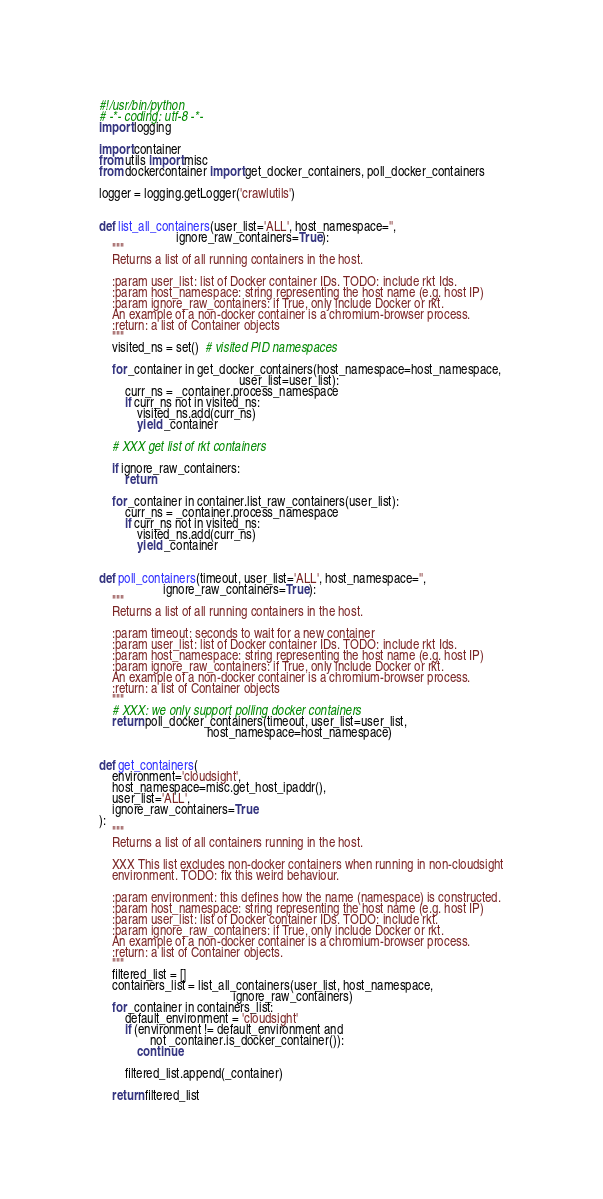<code> <loc_0><loc_0><loc_500><loc_500><_Python_>#!/usr/bin/python
# -*- coding: utf-8 -*-
import logging

import container
from utils import misc
from dockercontainer import get_docker_containers, poll_docker_containers

logger = logging.getLogger('crawlutils')


def list_all_containers(user_list='ALL', host_namespace='',
                        ignore_raw_containers=True):
    """
    Returns a list of all running containers in the host.

    :param user_list: list of Docker container IDs. TODO: include rkt Ids.
    :param host_namespace: string representing the host name (e.g. host IP)
    :param ignore_raw_containers: if True, only include Docker or rkt.
    An example of a non-docker container is a chromium-browser process.
    :return: a list of Container objects
    """
    visited_ns = set()  # visited PID namespaces

    for _container in get_docker_containers(host_namespace=host_namespace,
                                            user_list=user_list):
        curr_ns = _container.process_namespace
        if curr_ns not in visited_ns:
            visited_ns.add(curr_ns)
            yield _container

    # XXX get list of rkt containers

    if ignore_raw_containers:
        return

    for _container in container.list_raw_containers(user_list):
        curr_ns = _container.process_namespace
        if curr_ns not in visited_ns:
            visited_ns.add(curr_ns)
            yield _container


def poll_containers(timeout, user_list='ALL', host_namespace='',
                    ignore_raw_containers=True):
    """
    Returns a list of all running containers in the host.

    :param timeout: seconds to wait for a new container
    :param user_list: list of Docker container IDs. TODO: include rkt Ids.
    :param host_namespace: string representing the host name (e.g. host IP)
    :param ignore_raw_containers: if True, only include Docker or rkt.
    An example of a non-docker container is a chromium-browser process.
    :return: a list of Container objects
    """
    # XXX: we only support polling docker containers
    return poll_docker_containers(timeout, user_list=user_list,
                                  host_namespace=host_namespace)


def get_containers(
    environment='cloudsight',
    host_namespace=misc.get_host_ipaddr(),
    user_list='ALL',
    ignore_raw_containers=True
):
    """
    Returns a list of all containers running in the host.

    XXX This list excludes non-docker containers when running in non-cloudsight
    environment. TODO: fix this weird behaviour.

    :param environment: this defines how the name (namespace) is constructed.
    :param host_namespace: string representing the host name (e.g. host IP)
    :param user_list: list of Docker container IDs. TODO: include rkt.
    :param ignore_raw_containers: if True, only include Docker or rkt.
    An example of a non-docker container is a chromium-browser process.
    :return: a list of Container objects.
    """
    filtered_list = []
    containers_list = list_all_containers(user_list, host_namespace,
                                          ignore_raw_containers)
    for _container in containers_list:
        default_environment = 'cloudsight'
        if (environment != default_environment and
                not _container.is_docker_container()):
            continue

        filtered_list.append(_container)

    return filtered_list
</code> 